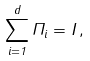<formula> <loc_0><loc_0><loc_500><loc_500>\sum _ { i = 1 } ^ { d } \Pi _ { i } = I \, ,</formula> 